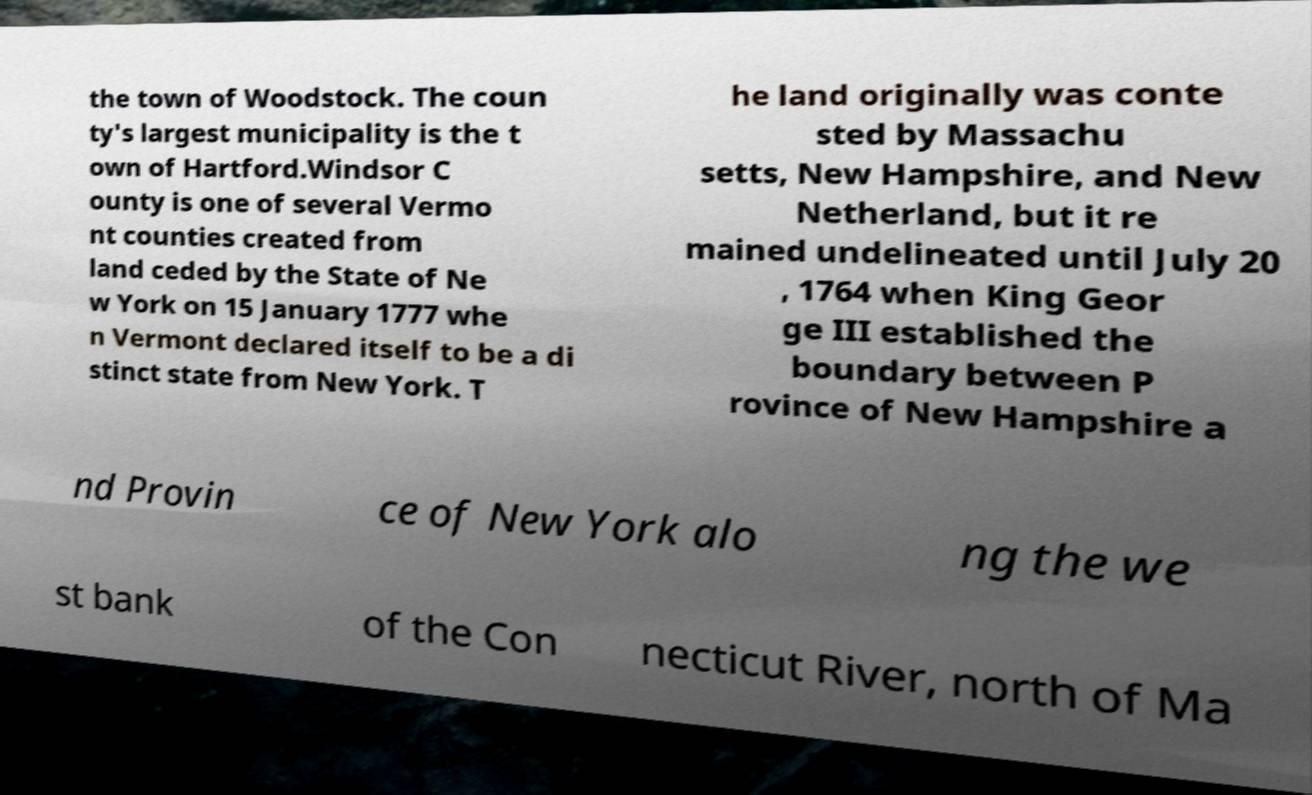For documentation purposes, I need the text within this image transcribed. Could you provide that? the town of Woodstock. The coun ty's largest municipality is the t own of Hartford.Windsor C ounty is one of several Vermo nt counties created from land ceded by the State of Ne w York on 15 January 1777 whe n Vermont declared itself to be a di stinct state from New York. T he land originally was conte sted by Massachu setts, New Hampshire, and New Netherland, but it re mained undelineated until July 20 , 1764 when King Geor ge III established the boundary between P rovince of New Hampshire a nd Provin ce of New York alo ng the we st bank of the Con necticut River, north of Ma 